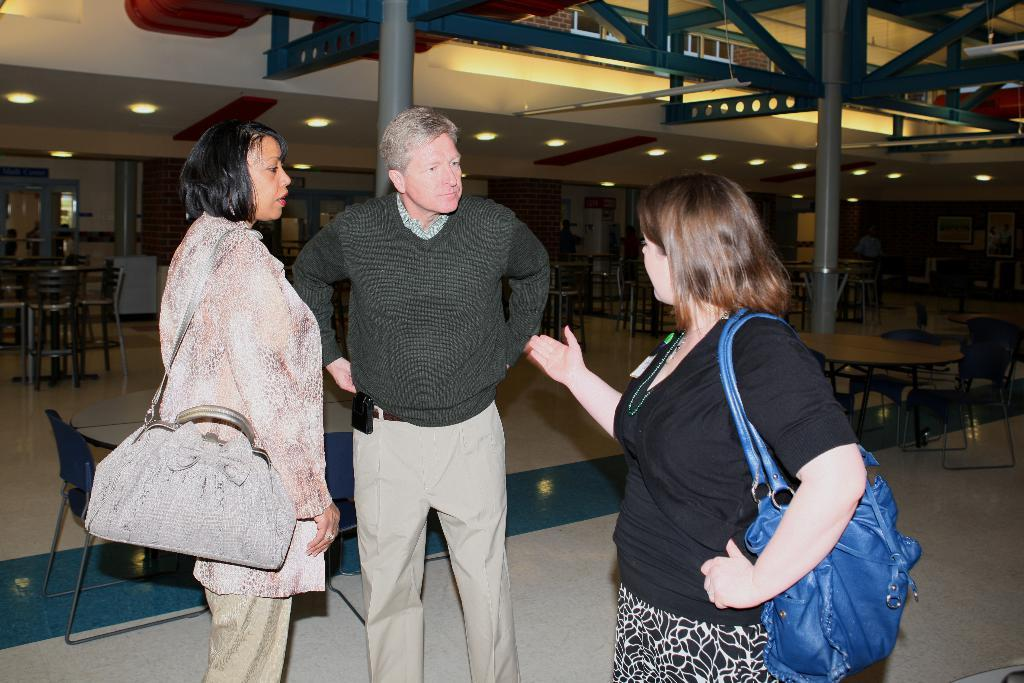How many people are in the image? There are two women and one man in the image. What are the individuals doing in the image? The individuals are standing and talking. What type of furniture can be seen in the background of the image? There are chairs and tables in the background of the image. What architectural features are visible in the background of the image? There are doors in the background of the image. What type of lighting is present in the background of the image? There are lights in the background of the image. What structural elements can be seen in the background of the image? There are poles in the background of the image. What type of kettle is being used by the man in the image? There is no kettle present in the image; the individuals are standing and talking. How does the man's breath affect the conversation in the image? There is no mention of the man's breath affecting the conversation in the image. 